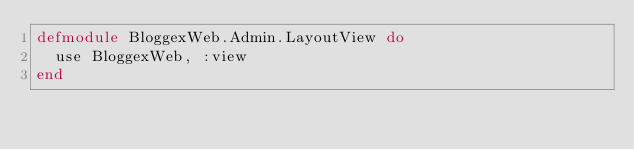Convert code to text. <code><loc_0><loc_0><loc_500><loc_500><_Elixir_>defmodule BloggexWeb.Admin.LayoutView do
  use BloggexWeb, :view
end
</code> 